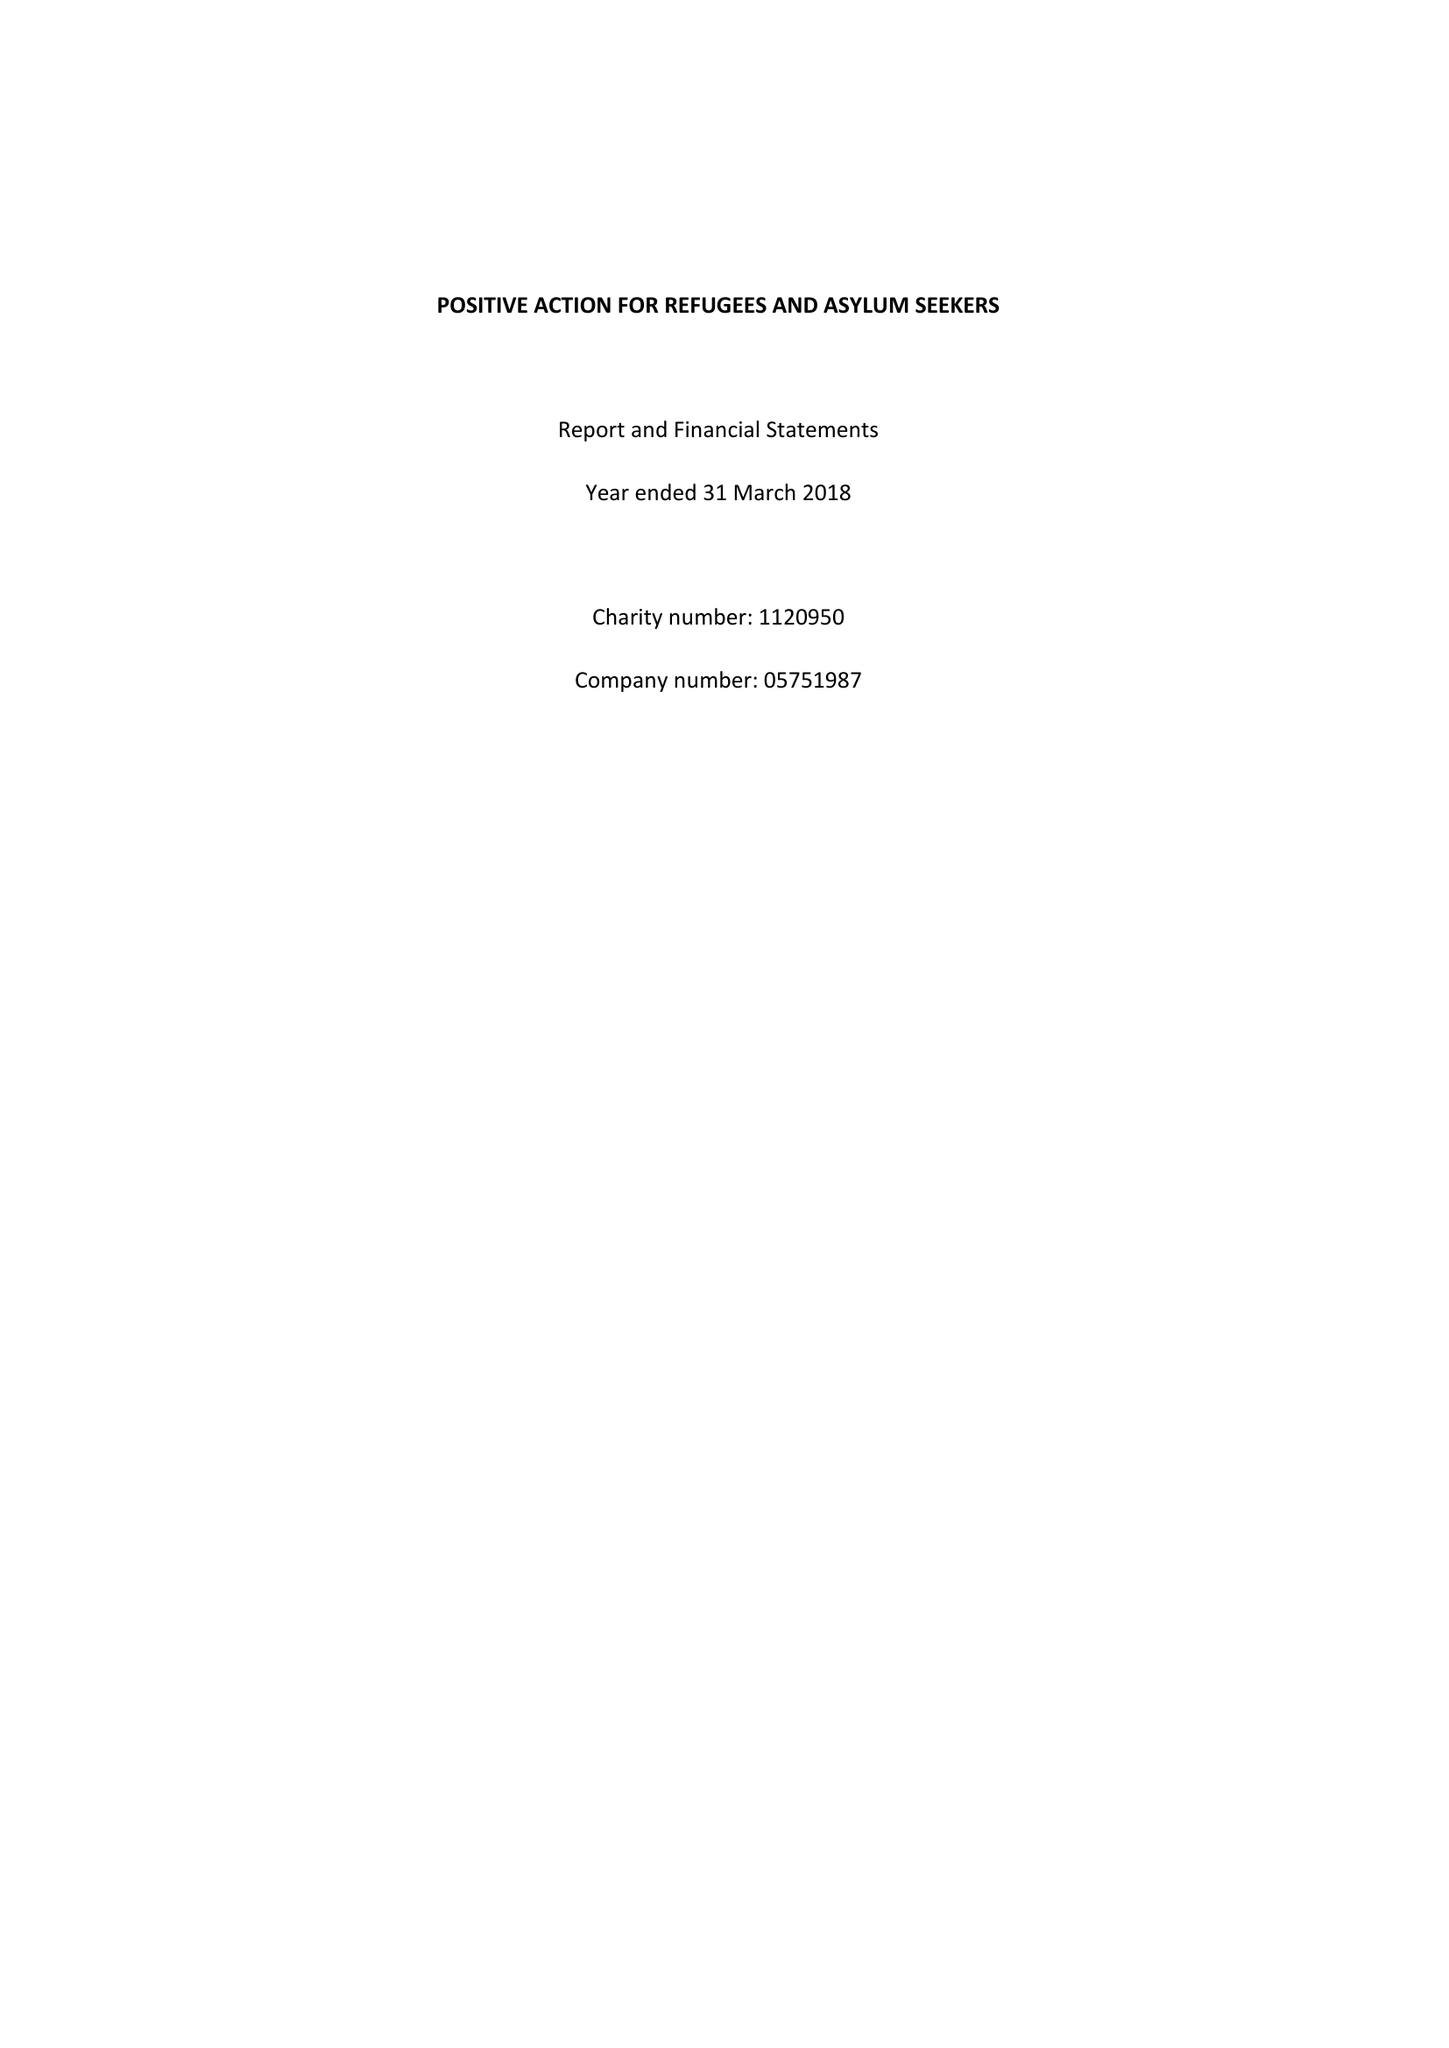What is the value for the report_date?
Answer the question using a single word or phrase. 2018-03-31 